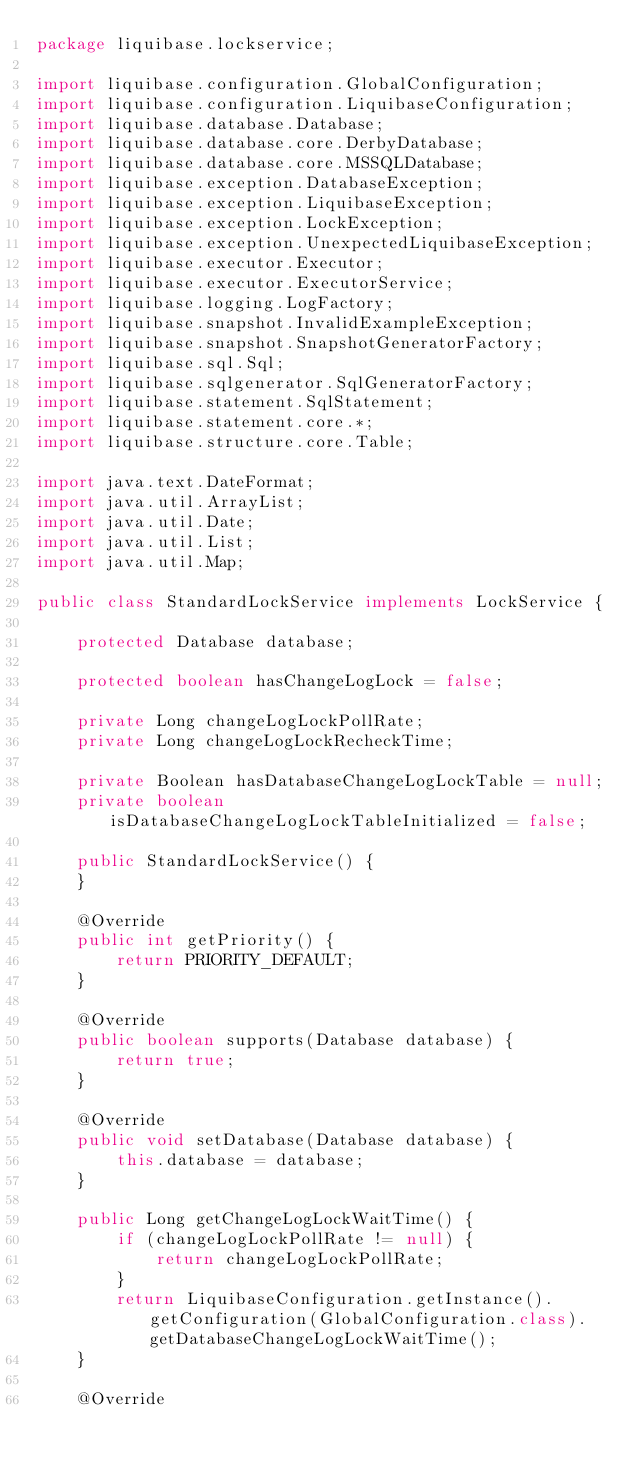<code> <loc_0><loc_0><loc_500><loc_500><_Java_>package liquibase.lockservice;

import liquibase.configuration.GlobalConfiguration;
import liquibase.configuration.LiquibaseConfiguration;
import liquibase.database.Database;
import liquibase.database.core.DerbyDatabase;
import liquibase.database.core.MSSQLDatabase;
import liquibase.exception.DatabaseException;
import liquibase.exception.LiquibaseException;
import liquibase.exception.LockException;
import liquibase.exception.UnexpectedLiquibaseException;
import liquibase.executor.Executor;
import liquibase.executor.ExecutorService;
import liquibase.logging.LogFactory;
import liquibase.snapshot.InvalidExampleException;
import liquibase.snapshot.SnapshotGeneratorFactory;
import liquibase.sql.Sql;
import liquibase.sqlgenerator.SqlGeneratorFactory;
import liquibase.statement.SqlStatement;
import liquibase.statement.core.*;
import liquibase.structure.core.Table;

import java.text.DateFormat;
import java.util.ArrayList;
import java.util.Date;
import java.util.List;
import java.util.Map;

public class StandardLockService implements LockService {

    protected Database database;

    protected boolean hasChangeLogLock = false;

    private Long changeLogLockPollRate;
    private Long changeLogLockRecheckTime;

    private Boolean hasDatabaseChangeLogLockTable = null;
    private boolean isDatabaseChangeLogLockTableInitialized = false;

    public StandardLockService() {
    }

    @Override
    public int getPriority() {
        return PRIORITY_DEFAULT;
    }

    @Override
    public boolean supports(Database database) {
        return true;
    }

    @Override
    public void setDatabase(Database database) {
        this.database = database;
    }

    public Long getChangeLogLockWaitTime() {
        if (changeLogLockPollRate != null) {
            return changeLogLockPollRate;
        }
        return LiquibaseConfiguration.getInstance().getConfiguration(GlobalConfiguration.class).getDatabaseChangeLogLockWaitTime();
    }

    @Override</code> 